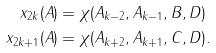Convert formula to latex. <formula><loc_0><loc_0><loc_500><loc_500>x _ { 2 k } ( A ) & = \chi ( A _ { k - 2 } , A _ { k - 1 } , B , D ) \\ x _ { 2 k + 1 } ( A ) & = \chi ( A _ { k + 2 } , A _ { k + 1 } , C , D ) .</formula> 